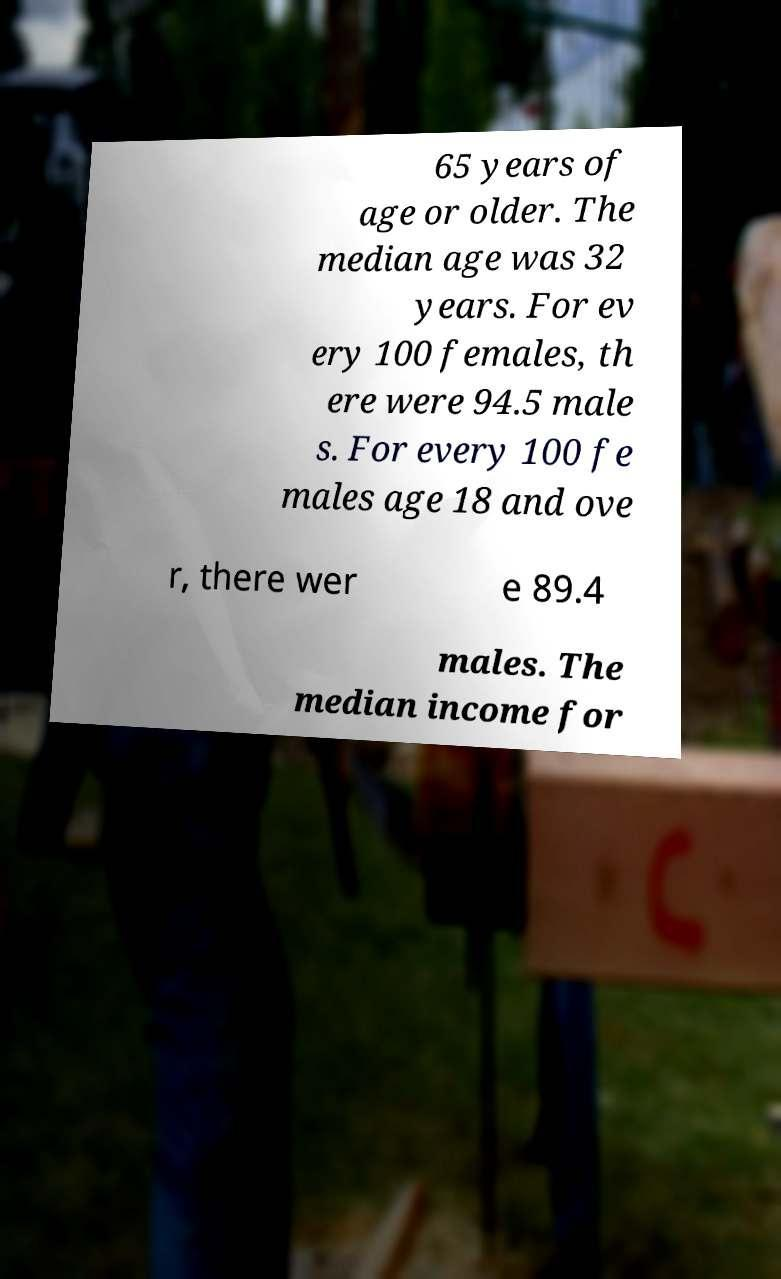What messages or text are displayed in this image? I need them in a readable, typed format. 65 years of age or older. The median age was 32 years. For ev ery 100 females, th ere were 94.5 male s. For every 100 fe males age 18 and ove r, there wer e 89.4 males. The median income for 